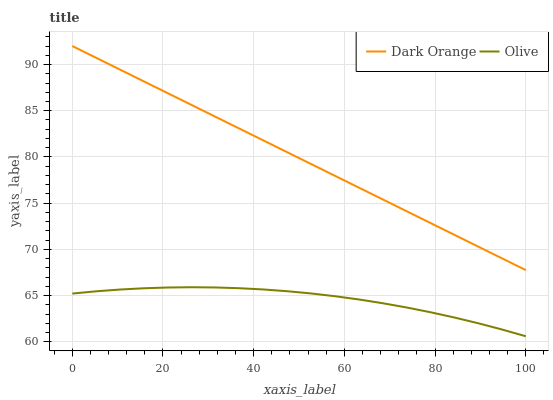Does Olive have the minimum area under the curve?
Answer yes or no. Yes. Does Dark Orange have the maximum area under the curve?
Answer yes or no. Yes. Does Dark Orange have the minimum area under the curve?
Answer yes or no. No. Is Dark Orange the smoothest?
Answer yes or no. Yes. Is Olive the roughest?
Answer yes or no. Yes. Is Dark Orange the roughest?
Answer yes or no. No. Does Dark Orange have the lowest value?
Answer yes or no. No. Does Dark Orange have the highest value?
Answer yes or no. Yes. Is Olive less than Dark Orange?
Answer yes or no. Yes. Is Dark Orange greater than Olive?
Answer yes or no. Yes. Does Olive intersect Dark Orange?
Answer yes or no. No. 